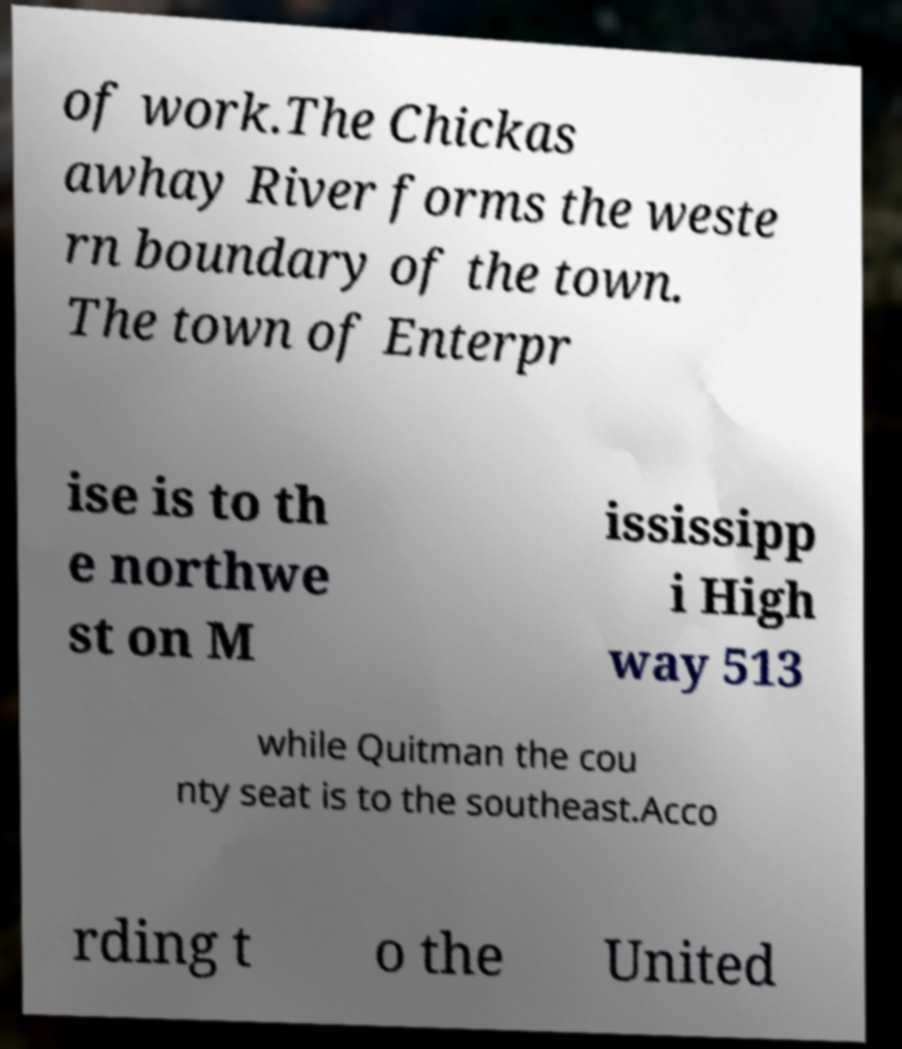For documentation purposes, I need the text within this image transcribed. Could you provide that? of work.The Chickas awhay River forms the weste rn boundary of the town. The town of Enterpr ise is to th e northwe st on M ississipp i High way 513 while Quitman the cou nty seat is to the southeast.Acco rding t o the United 